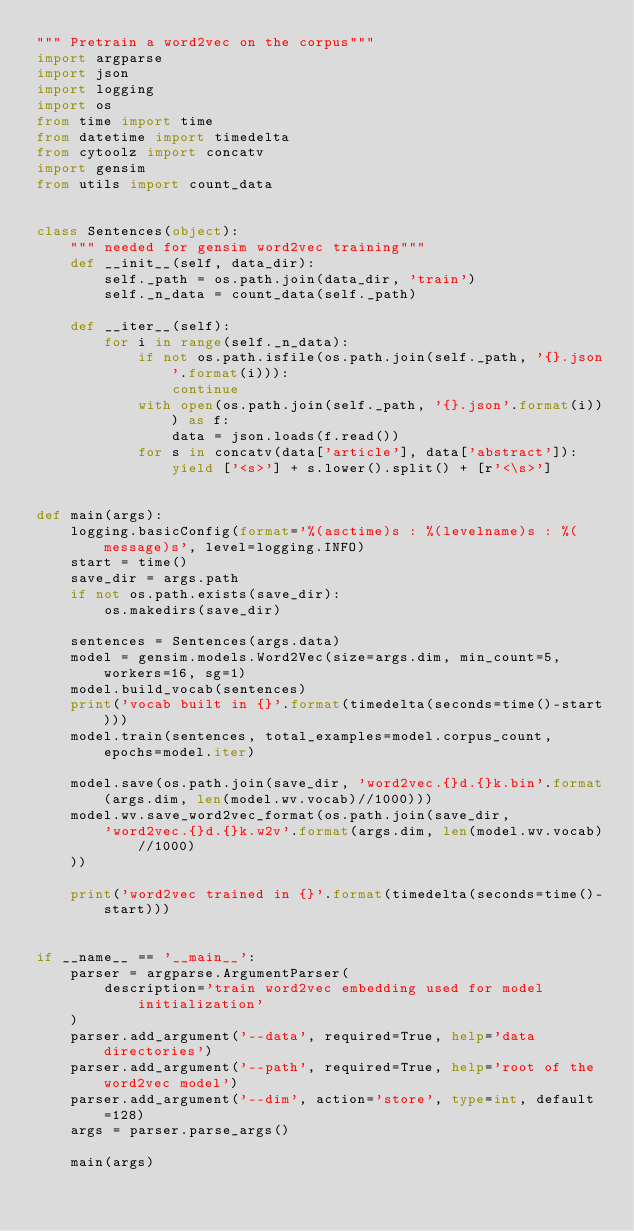<code> <loc_0><loc_0><loc_500><loc_500><_Python_>""" Pretrain a word2vec on the corpus"""
import argparse
import json
import logging
import os
from time import time
from datetime import timedelta
from cytoolz import concatv
import gensim
from utils import count_data


class Sentences(object):
    """ needed for gensim word2vec training"""
    def __init__(self, data_dir):
        self._path = os.path.join(data_dir, 'train')
        self._n_data = count_data(self._path)

    def __iter__(self):
        for i in range(self._n_data):
            if not os.path.isfile(os.path.join(self._path, '{}.json'.format(i))):
                continue
            with open(os.path.join(self._path, '{}.json'.format(i))) as f:
                data = json.loads(f.read())
            for s in concatv(data['article'], data['abstract']):
                yield ['<s>'] + s.lower().split() + [r'<\s>']


def main(args):
    logging.basicConfig(format='%(asctime)s : %(levelname)s : %(message)s', level=logging.INFO)
    start = time()
    save_dir = args.path
    if not os.path.exists(save_dir):
        os.makedirs(save_dir)

    sentences = Sentences(args.data)
    model = gensim.models.Word2Vec(size=args.dim, min_count=5, workers=16, sg=1)
    model.build_vocab(sentences)
    print('vocab built in {}'.format(timedelta(seconds=time()-start)))
    model.train(sentences, total_examples=model.corpus_count, epochs=model.iter)

    model.save(os.path.join(save_dir, 'word2vec.{}d.{}k.bin'.format(args.dim, len(model.wv.vocab)//1000)))
    model.wv.save_word2vec_format(os.path.join(save_dir,
        'word2vec.{}d.{}k.w2v'.format(args.dim, len(model.wv.vocab)//1000)
    ))

    print('word2vec trained in {}'.format(timedelta(seconds=time()-start)))


if __name__ == '__main__':
    parser = argparse.ArgumentParser(
        description='train word2vec embedding used for model initialization'
    )
    parser.add_argument('--data', required=True, help='data directories')
    parser.add_argument('--path', required=True, help='root of the word2vec model')
    parser.add_argument('--dim', action='store', type=int, default=128)
    args = parser.parse_args()

    main(args)
</code> 